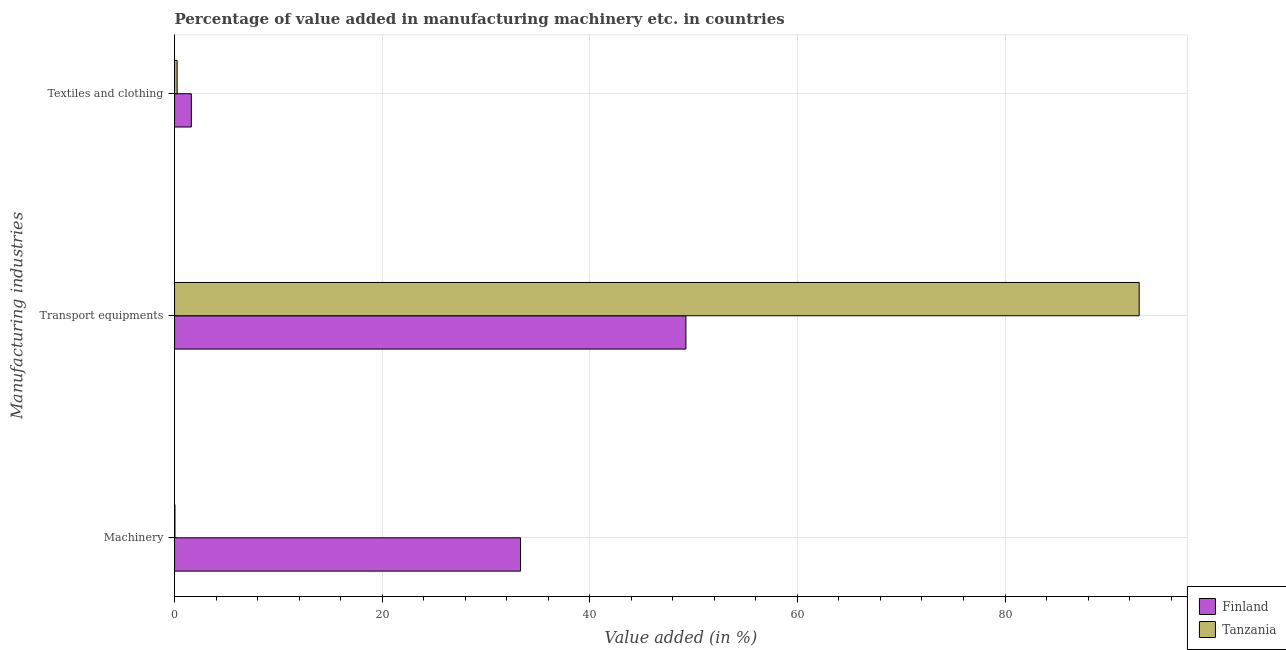How many different coloured bars are there?
Your answer should be very brief. 2. How many groups of bars are there?
Keep it short and to the point. 3. How many bars are there on the 1st tick from the top?
Keep it short and to the point. 2. What is the label of the 1st group of bars from the top?
Offer a very short reply. Textiles and clothing. What is the value added in manufacturing machinery in Finland?
Provide a succinct answer. 33.33. Across all countries, what is the maximum value added in manufacturing textile and clothing?
Offer a terse response. 1.62. Across all countries, what is the minimum value added in manufacturing machinery?
Keep it short and to the point. 0.04. In which country was the value added in manufacturing machinery maximum?
Offer a terse response. Finland. In which country was the value added in manufacturing textile and clothing minimum?
Keep it short and to the point. Tanzania. What is the total value added in manufacturing textile and clothing in the graph?
Provide a succinct answer. 1.87. What is the difference between the value added in manufacturing machinery in Finland and that in Tanzania?
Make the answer very short. 33.29. What is the difference between the value added in manufacturing machinery in Tanzania and the value added in manufacturing textile and clothing in Finland?
Make the answer very short. -1.58. What is the average value added in manufacturing textile and clothing per country?
Your answer should be very brief. 0.93. What is the difference between the value added in manufacturing machinery and value added in manufacturing transport equipments in Tanzania?
Provide a succinct answer. -92.89. What is the ratio of the value added in manufacturing machinery in Finland to that in Tanzania?
Make the answer very short. 855.08. What is the difference between the highest and the second highest value added in manufacturing machinery?
Your answer should be very brief. 33.29. What is the difference between the highest and the lowest value added in manufacturing machinery?
Your response must be concise. 33.29. Is the sum of the value added in manufacturing machinery in Tanzania and Finland greater than the maximum value added in manufacturing transport equipments across all countries?
Provide a succinct answer. No. What does the 2nd bar from the top in Machinery represents?
Keep it short and to the point. Finland. Are all the bars in the graph horizontal?
Make the answer very short. Yes. What is the difference between two consecutive major ticks on the X-axis?
Your answer should be very brief. 20. Does the graph contain grids?
Your answer should be compact. Yes. How many legend labels are there?
Provide a short and direct response. 2. What is the title of the graph?
Your answer should be compact. Percentage of value added in manufacturing machinery etc. in countries. Does "Libya" appear as one of the legend labels in the graph?
Provide a short and direct response. No. What is the label or title of the X-axis?
Offer a very short reply. Value added (in %). What is the label or title of the Y-axis?
Keep it short and to the point. Manufacturing industries. What is the Value added (in %) in Finland in Machinery?
Give a very brief answer. 33.33. What is the Value added (in %) of Tanzania in Machinery?
Your answer should be very brief. 0.04. What is the Value added (in %) of Finland in Transport equipments?
Make the answer very short. 49.26. What is the Value added (in %) of Tanzania in Transport equipments?
Your answer should be very brief. 92.93. What is the Value added (in %) of Finland in Textiles and clothing?
Make the answer very short. 1.62. What is the Value added (in %) of Tanzania in Textiles and clothing?
Your answer should be compact. 0.25. Across all Manufacturing industries, what is the maximum Value added (in %) in Finland?
Give a very brief answer. 49.26. Across all Manufacturing industries, what is the maximum Value added (in %) in Tanzania?
Keep it short and to the point. 92.93. Across all Manufacturing industries, what is the minimum Value added (in %) in Finland?
Offer a terse response. 1.62. Across all Manufacturing industries, what is the minimum Value added (in %) in Tanzania?
Provide a succinct answer. 0.04. What is the total Value added (in %) in Finland in the graph?
Offer a terse response. 84.21. What is the total Value added (in %) of Tanzania in the graph?
Your answer should be very brief. 93.21. What is the difference between the Value added (in %) in Finland in Machinery and that in Transport equipments?
Your answer should be compact. -15.93. What is the difference between the Value added (in %) of Tanzania in Machinery and that in Transport equipments?
Offer a terse response. -92.89. What is the difference between the Value added (in %) in Finland in Machinery and that in Textiles and clothing?
Offer a terse response. 31.72. What is the difference between the Value added (in %) of Tanzania in Machinery and that in Textiles and clothing?
Make the answer very short. -0.21. What is the difference between the Value added (in %) of Finland in Transport equipments and that in Textiles and clothing?
Your answer should be very brief. 47.64. What is the difference between the Value added (in %) of Tanzania in Transport equipments and that in Textiles and clothing?
Offer a very short reply. 92.68. What is the difference between the Value added (in %) in Finland in Machinery and the Value added (in %) in Tanzania in Transport equipments?
Ensure brevity in your answer.  -59.59. What is the difference between the Value added (in %) in Finland in Machinery and the Value added (in %) in Tanzania in Textiles and clothing?
Provide a short and direct response. 33.08. What is the difference between the Value added (in %) of Finland in Transport equipments and the Value added (in %) of Tanzania in Textiles and clothing?
Ensure brevity in your answer.  49.01. What is the average Value added (in %) of Finland per Manufacturing industries?
Your answer should be compact. 28.07. What is the average Value added (in %) of Tanzania per Manufacturing industries?
Offer a terse response. 31.07. What is the difference between the Value added (in %) in Finland and Value added (in %) in Tanzania in Machinery?
Ensure brevity in your answer.  33.29. What is the difference between the Value added (in %) in Finland and Value added (in %) in Tanzania in Transport equipments?
Ensure brevity in your answer.  -43.66. What is the difference between the Value added (in %) of Finland and Value added (in %) of Tanzania in Textiles and clothing?
Provide a succinct answer. 1.37. What is the ratio of the Value added (in %) of Finland in Machinery to that in Transport equipments?
Make the answer very short. 0.68. What is the ratio of the Value added (in %) of Finland in Machinery to that in Textiles and clothing?
Give a very brief answer. 20.63. What is the ratio of the Value added (in %) in Tanzania in Machinery to that in Textiles and clothing?
Provide a succinct answer. 0.16. What is the ratio of the Value added (in %) of Finland in Transport equipments to that in Textiles and clothing?
Ensure brevity in your answer.  30.49. What is the ratio of the Value added (in %) in Tanzania in Transport equipments to that in Textiles and clothing?
Provide a succinct answer. 372.62. What is the difference between the highest and the second highest Value added (in %) in Finland?
Offer a terse response. 15.93. What is the difference between the highest and the second highest Value added (in %) of Tanzania?
Give a very brief answer. 92.68. What is the difference between the highest and the lowest Value added (in %) of Finland?
Keep it short and to the point. 47.64. What is the difference between the highest and the lowest Value added (in %) in Tanzania?
Make the answer very short. 92.89. 